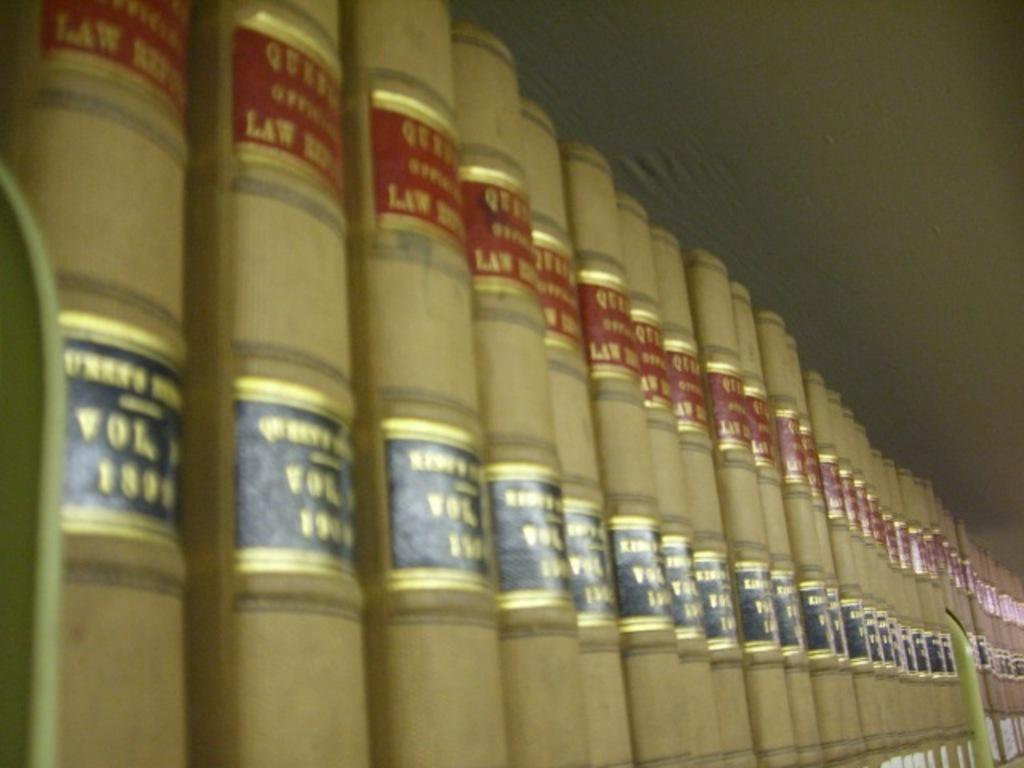<image>
Write a terse but informative summary of the picture. Brown law books with red and black labels are lined up on a shelf. 